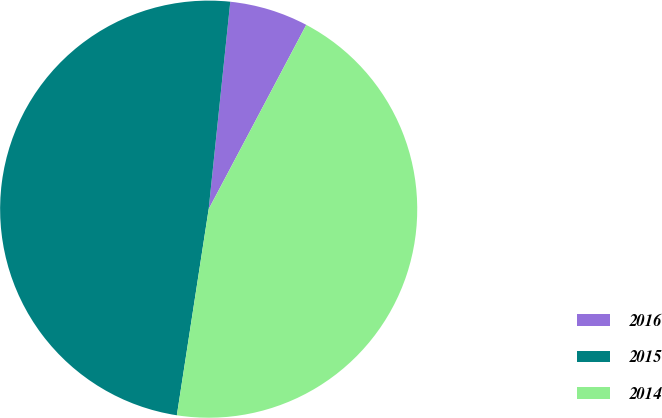<chart> <loc_0><loc_0><loc_500><loc_500><pie_chart><fcel>2016<fcel>2015<fcel>2014<nl><fcel>6.1%<fcel>49.22%<fcel>44.69%<nl></chart> 